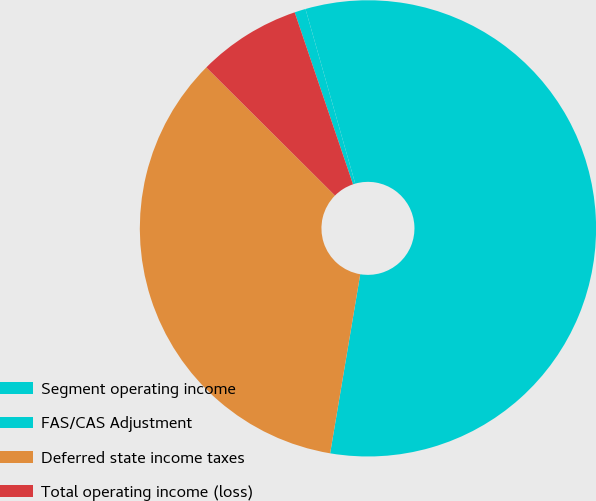<chart> <loc_0><loc_0><loc_500><loc_500><pie_chart><fcel>Segment operating income<fcel>FAS/CAS Adjustment<fcel>Deferred state income taxes<fcel>Total operating income (loss)<nl><fcel>0.79%<fcel>57.07%<fcel>34.82%<fcel>7.33%<nl></chart> 